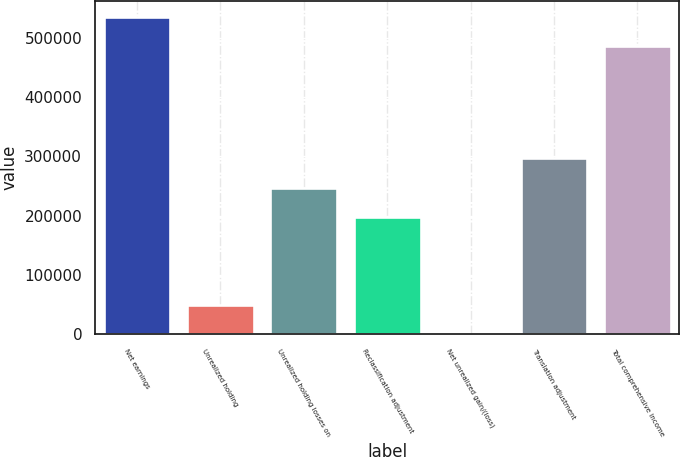<chart> <loc_0><loc_0><loc_500><loc_500><bar_chart><fcel>Net earnings<fcel>Unrealized holding<fcel>Unrealized holding losses on<fcel>Reclassification adjustment<fcel>Net unrealized gain/(loss)<fcel>Translation adjustment<fcel>Total comprehensive income<nl><fcel>535445<fcel>49752<fcel>247360<fcel>197958<fcel>350<fcel>296762<fcel>486043<nl></chart> 